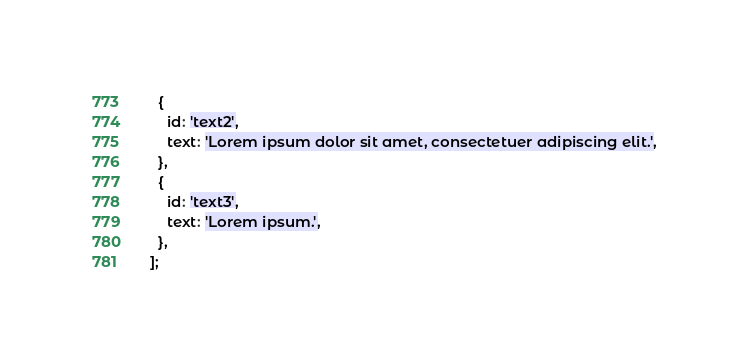Convert code to text. <code><loc_0><loc_0><loc_500><loc_500><_JavaScript_>  {
    id: 'text2',
    text: 'Lorem ipsum dolor sit amet, consectetuer adipiscing elit.',
  },
  {
    id: 'text3',
    text: 'Lorem ipsum.',
  },
];
</code> 